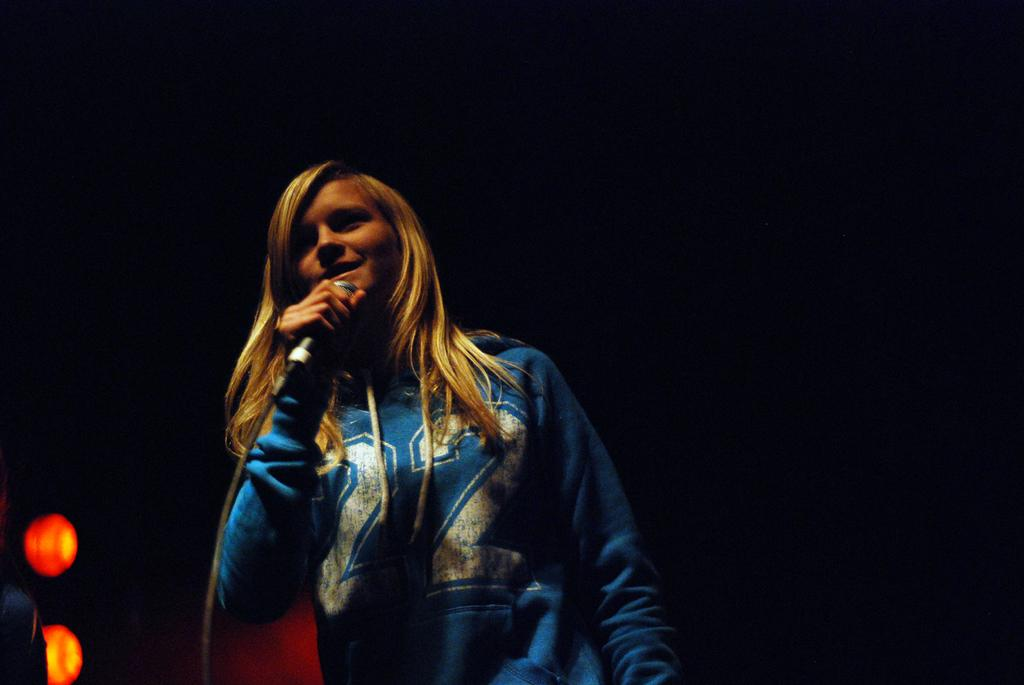Who is the main subject in the image? There is a woman in the image. What is the woman holding in the image? The woman is holding a microphone. What might the woman be doing based on her posture and the presence of the microphone? The woman's mouth is open, suggesting she is singing. What color is the crayon the woman is using to draw in the image? There is no crayon present in the image; the woman is holding a microphone and appears to be singing. 